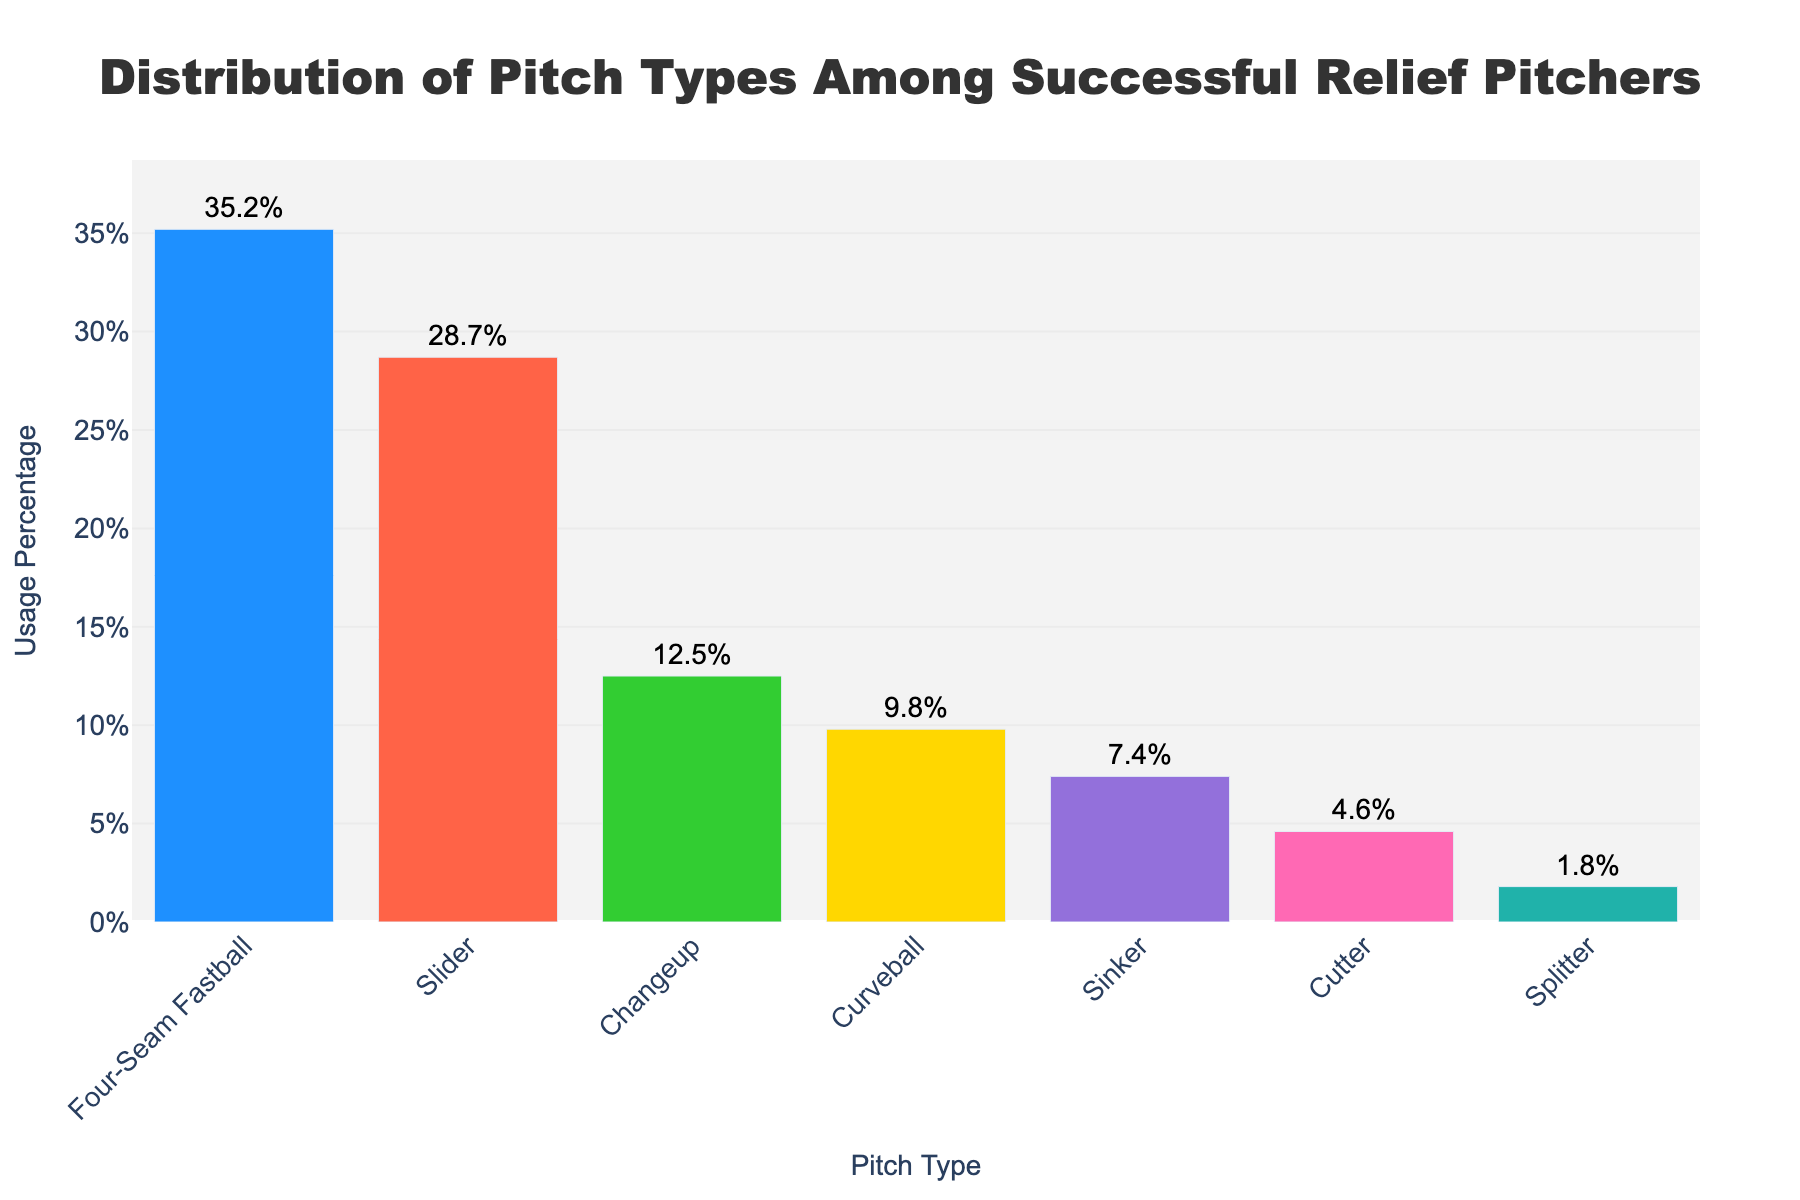What pitch type is used the most among successful relief pitchers? The figure shows that Four-Seam Fastball has the highest bar with a Usage Percentage of 35.2%, making it the most used pitch type.
Answer: Four-Seam Fastball Which pitch type has a usage percentage closest to 10%? The figure shows the Curveball with a Usage Percentage of 9.8%, which is closest to 10% compared to other pitch types.
Answer: Curveball What is the total combined usage percentage of the Slider and Changeup? The Slider has a usage percentage of 28.7% and the Changeup has 12.5%. Adding these gives 28.7 + 12.5 = 41.2%.
Answer: 41.2% Is the usage percentage of the Sinker greater than that of the Cutter? The Sinker has a usage percentage of 7.4%, while the Cutter has 4.6%. Since 7.4 is greater than 4.6, the Sinker is used more.
Answer: Yes Which pitch type is used the least among successful relief pitchers? The figure shows that the Splitter has the smallest bar with a Usage Percentage of 1.8%, making it the least used pitch type.
Answer: Splitter How much more is the usage percentage of the Four-Seam Fastball compared to the Sinker? The Four-Seam Fastball has a usage percentage of 35.2% and the Sinker has 7.4%. The difference is 35.2 - 7.4 = 27.8%.
Answer: 27.8% What is the average usage percentage of the Four-Seam Fastball, Slider, and Changeup? The Four-Seam Fastball has 35.2%, Slider 28.7%, and Changeup 12.5%. The average is (35.2 + 28.7 + 12.5) / 3 = 25.4667%.
Answer: 25.47% Compare the usage percentage of the Curveball and the Sinker. Which one is used more frequently? The Curveball has a usage percentage of 9.8% while the Sinker has 7.4%, so the Curveball is used more frequently.
Answer: Curveball What is the sum of the usage percentages of all pitch types displayed in the figure? Adding all the usage percentages: 35.2 + 28.7 + 12.5 + 9.8 + 7.4 + 4.6 + 1.8 = 100%.
Answer: 100% 